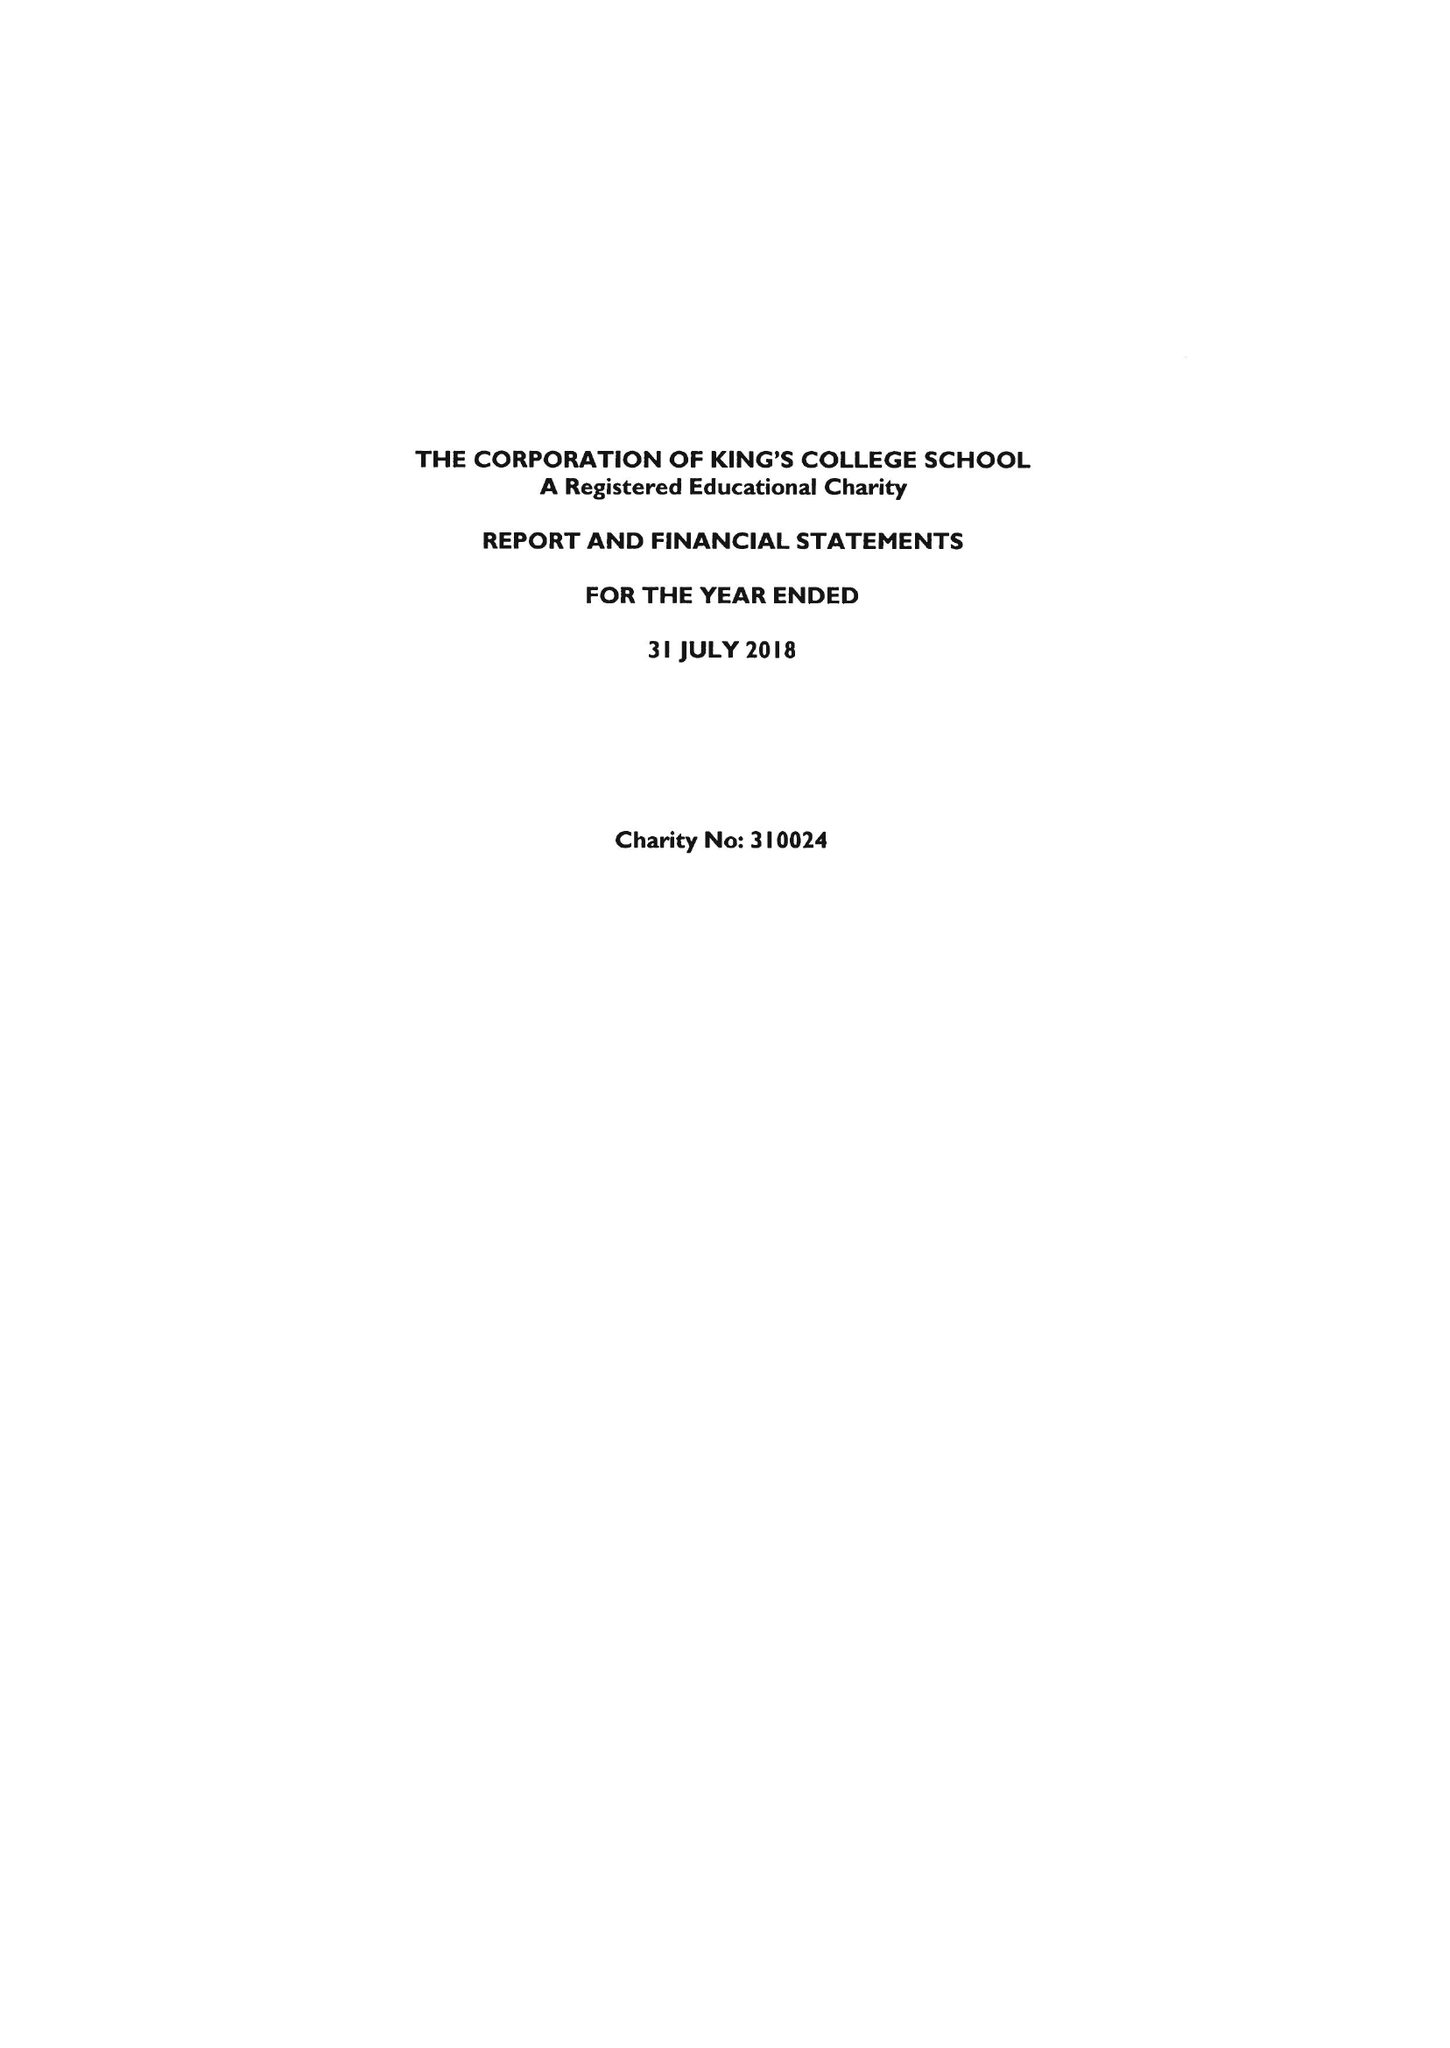What is the value for the charity_number?
Answer the question using a single word or phrase. 310024 